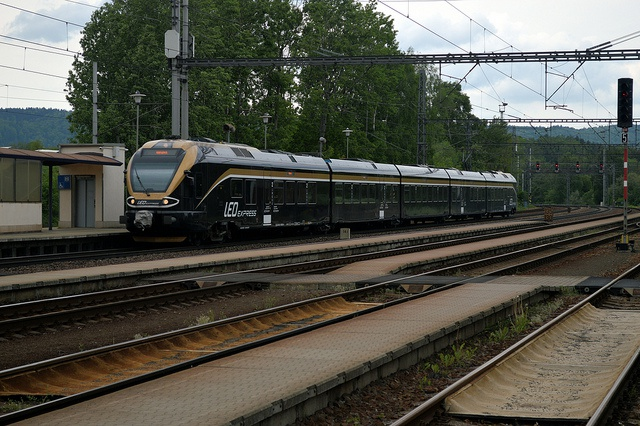Describe the objects in this image and their specific colors. I can see train in ivory, black, gray, darkgray, and olive tones, traffic light in ivory, black, and gray tones, traffic light in ivory, black, purple, and darkgreen tones, traffic light in ivory, black, darkblue, and maroon tones, and traffic light in ivory, black, purple, maroon, and darkgreen tones in this image. 